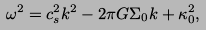Convert formula to latex. <formula><loc_0><loc_0><loc_500><loc_500>\omega ^ { 2 } = c _ { s } ^ { 2 } k ^ { 2 } - 2 \pi G \Sigma _ { 0 } k + \kappa _ { 0 } ^ { 2 } ,</formula> 